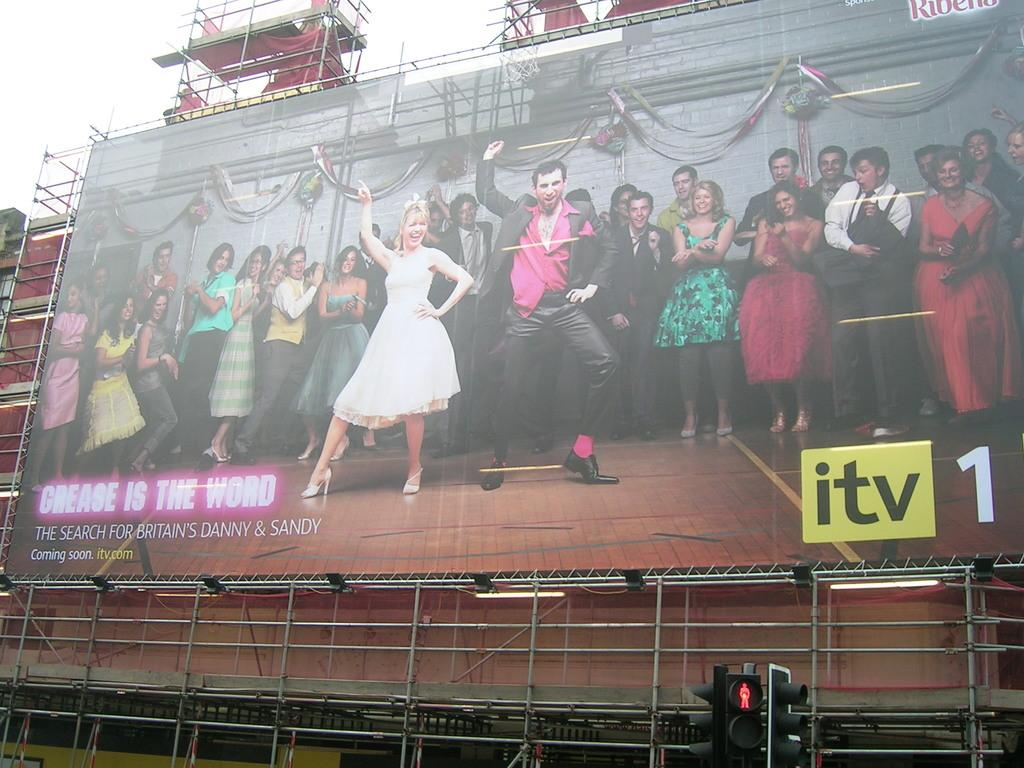Provide a one-sentence caption for the provided image. a banner that has the letters itv in the corner. 